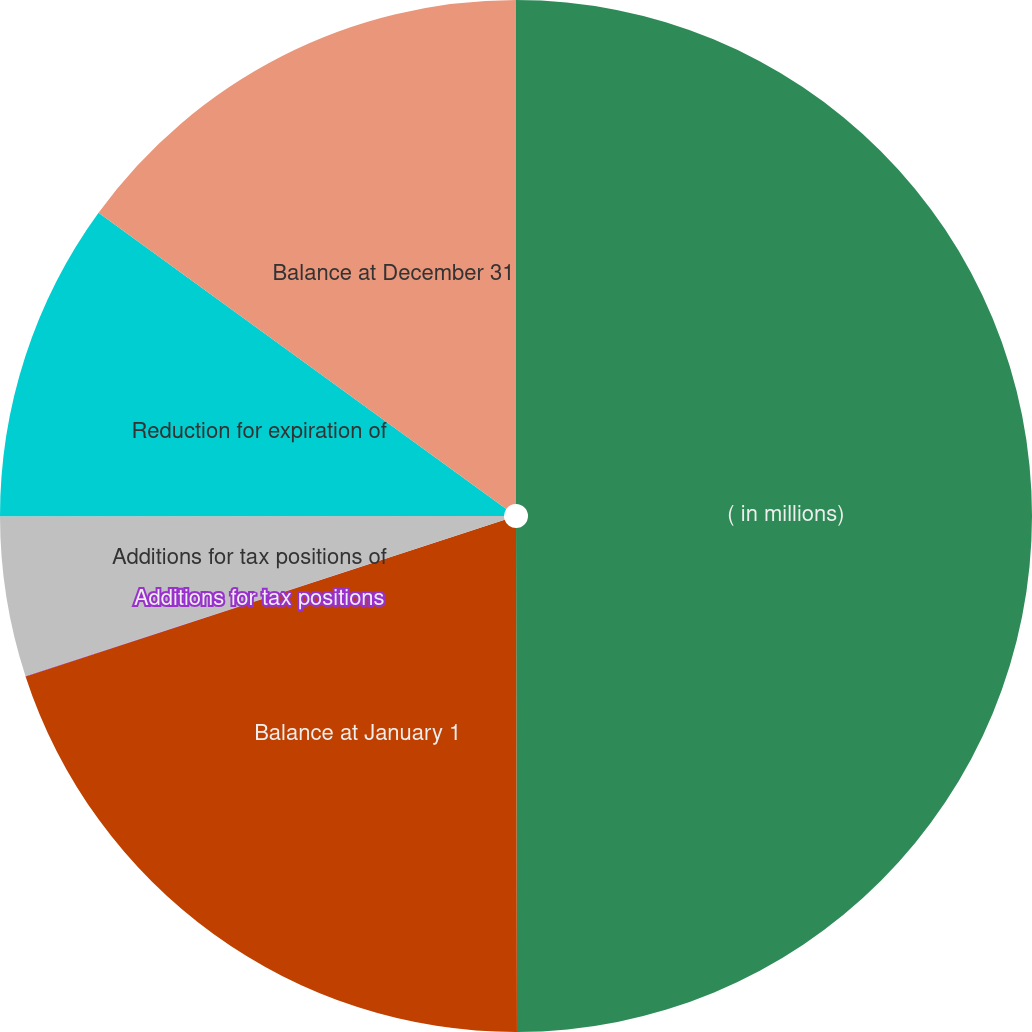Convert chart. <chart><loc_0><loc_0><loc_500><loc_500><pie_chart><fcel>( in millions)<fcel>Balance at January 1<fcel>Additions for tax positions<fcel>Additions for tax positions of<fcel>Reduction for expiration of<fcel>Balance at December 31<nl><fcel>49.97%<fcel>20.0%<fcel>0.01%<fcel>5.01%<fcel>10.01%<fcel>15.0%<nl></chart> 